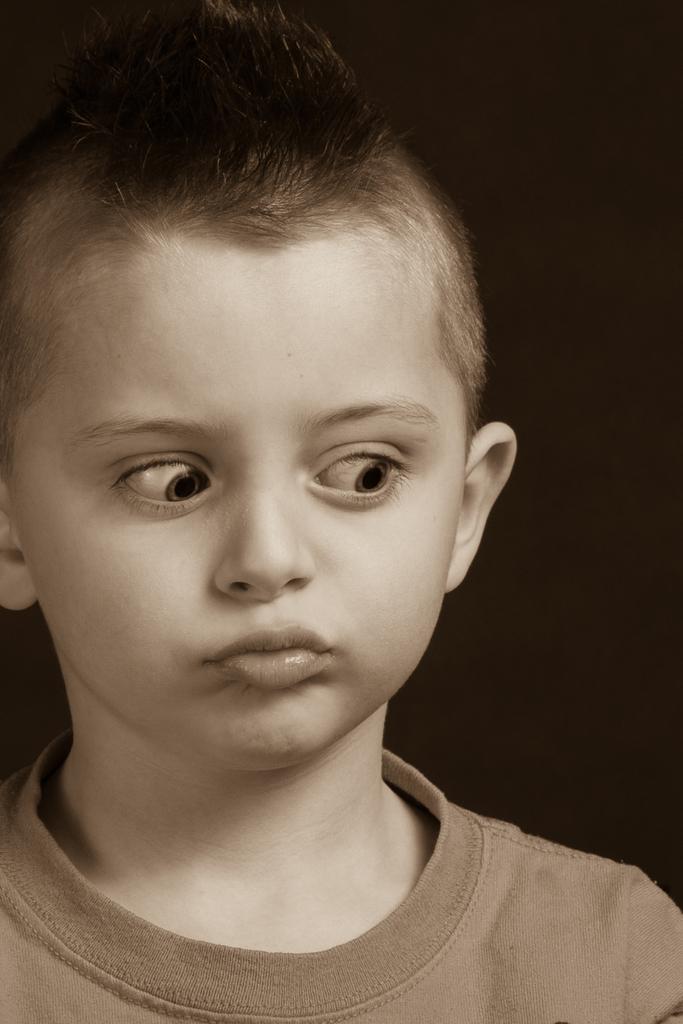Describe this image in one or two sentences. This is a black and image. In this image there is a boy. In the background it is dark. 